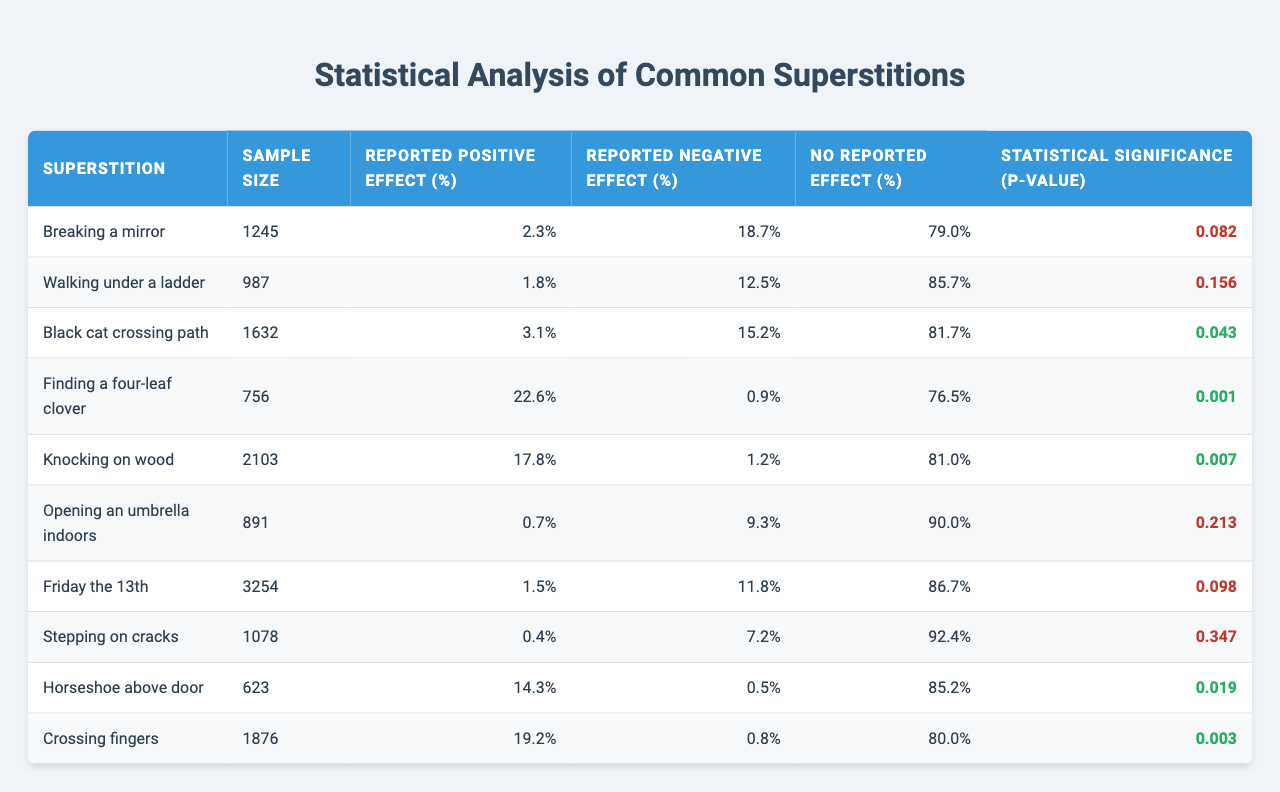What is the reported positive effect percentage for "Finding a four-leaf clover"? According to the table, the reported positive effect for "Finding a four-leaf clover" is 22.6%.
Answer: 22.6% How many people reported a negative effect from "Crossing fingers"? The table indicates that 0.8% of respondents reported a negative effect from "Crossing fingers".
Answer: 0.8% Which superstition has the highest reported positive effect? By comparing the reported positive effect percentages, "Finding a four-leaf clover" has the highest at 22.6%.
Answer: Finding a four-leaf clover What is the p-value for "Knocking on wood"? The table lists the p-value for "Knocking on wood" as 0.007.
Answer: 0.007 Is there a superstition among those listed that has a reported negative effect greater than 15%? Yes, "Breaking a mirror" has a reported negative effect of 18.7%.
Answer: Yes Calculate the average reported positive effect percentage for all superstitions. The positive effects are 2.3, 1.8, 3.1, 22.6, 17.8, 0.7, 1.5, 0.4, 14.3, and 19.2. Adding these values gives 83.4 and dividing by the sample size of 10 gives an average of 8.34%.
Answer: 8.34% Which superstition has the lowest reported positive effect? Comparing the reported positive effects, "Opening an umbrella indoors" has the lowest at 0.7%.
Answer: Opening an umbrella indoors How many superstitions show a statistically significant effect (p-value < 0.05)? The superstitions with p-values less than 0.05 are "Finding a four-leaf clover", "Knocking on wood", "Horseshoe above door", and "Crossing fingers", totaling four.
Answer: 4 What percentage of respondents reported no effect for "Horseshoe above door"? The table shows that 85.2% of respondents reported no effect from "Horseshoe above door".
Answer: 85.2% Is the superstition "Friday the 13th" associated with a statistically significant negative effect? No, since the p-value for "Friday the 13th" is 0.098, which is greater than 0.05, indicating no statistically significant effect.
Answer: No Which superstition, with over 1000 respondents, reported a positive effect of 1.5% or lower? The superstitions with over 1000 respondents and a positive effect of 1.5% or lower are "Friday the 13th" with 1.5% and "Stepping on cracks" with 0.4%.
Answer: Friday the 13th, Stepping on cracks 